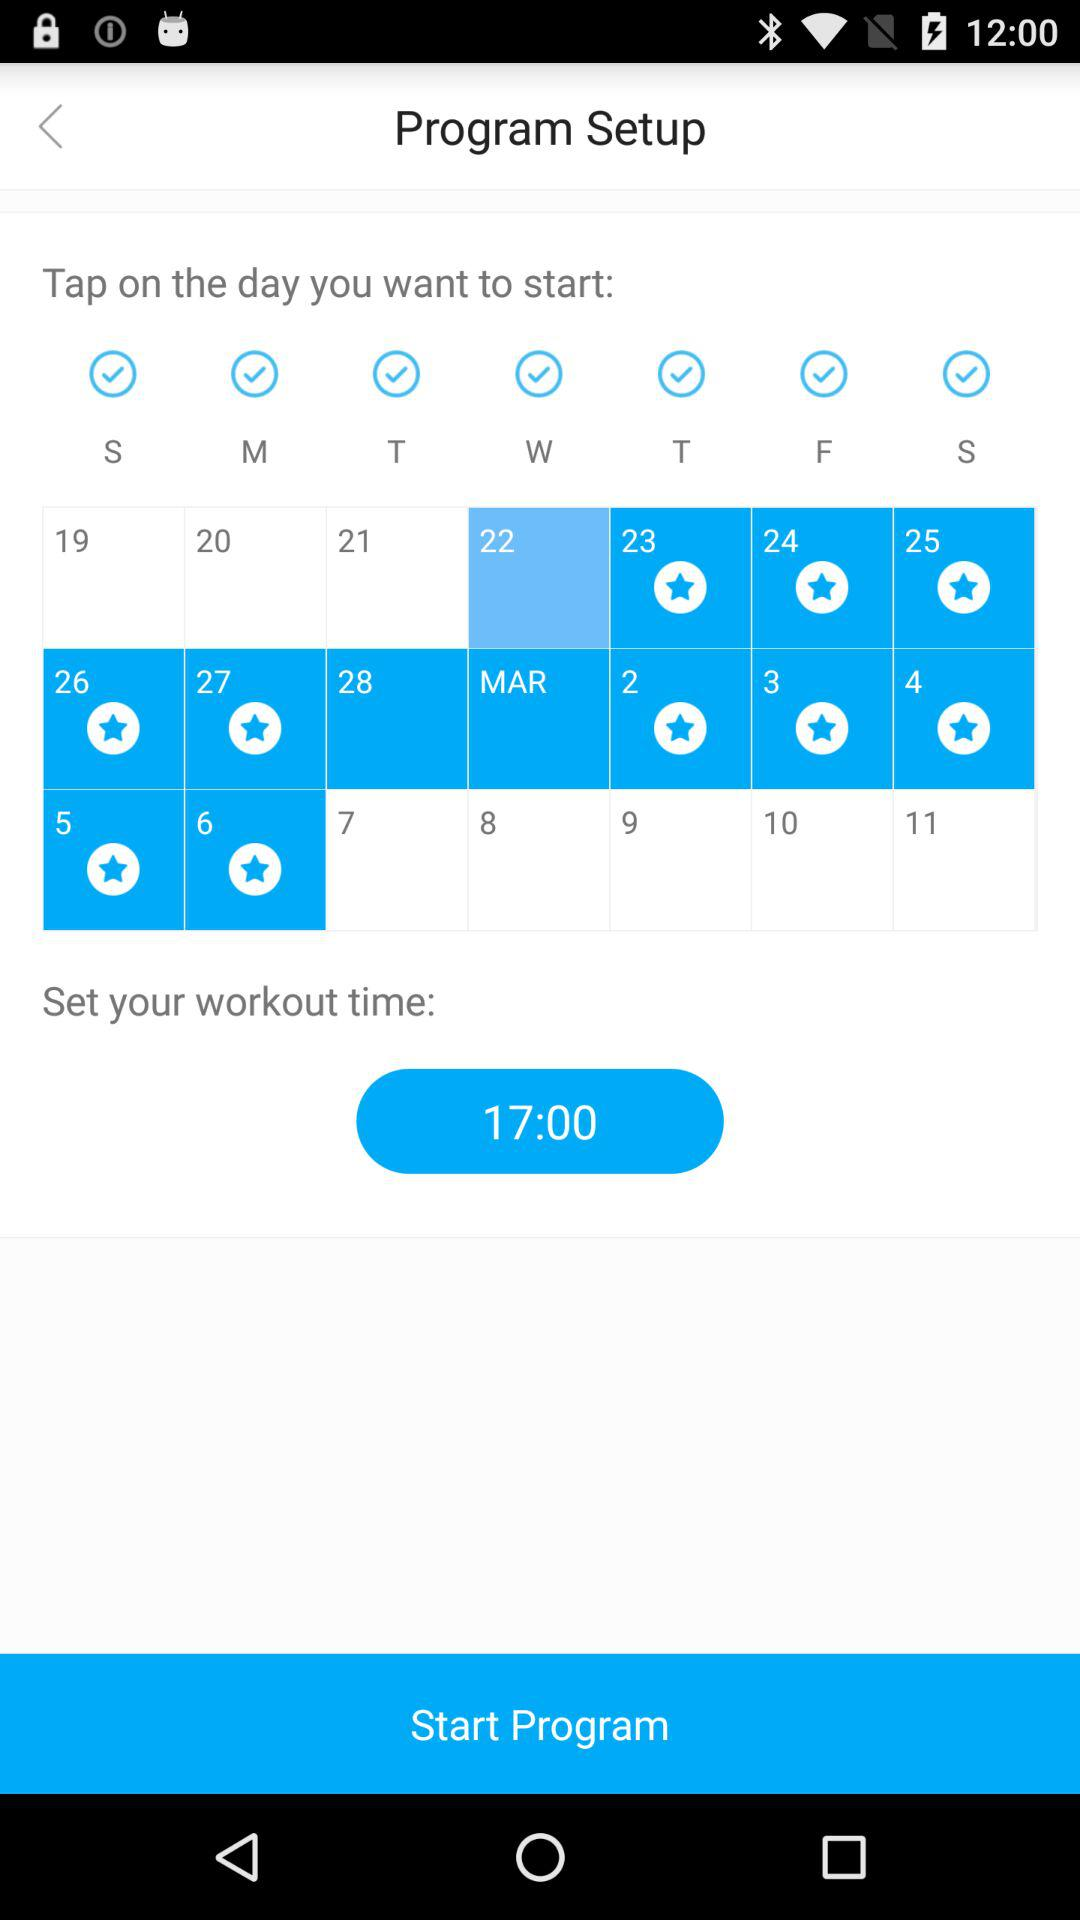What is the set workout time? The set workout time is 17:00. 